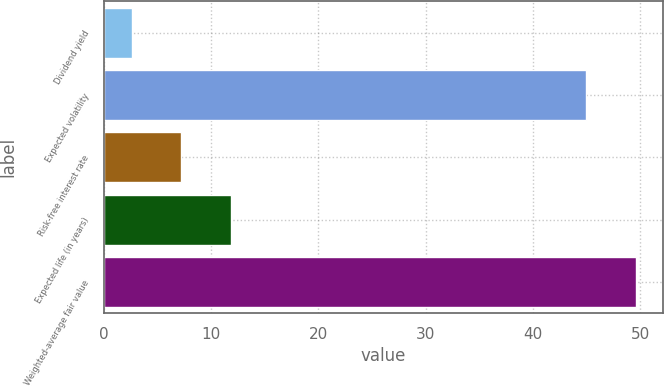Convert chart. <chart><loc_0><loc_0><loc_500><loc_500><bar_chart><fcel>Dividend yield<fcel>Expected volatility<fcel>Risk-free interest rate<fcel>Expected life (in years)<fcel>Weighted-average fair value<nl><fcel>2.6<fcel>45<fcel>7.22<fcel>11.84<fcel>49.62<nl></chart> 